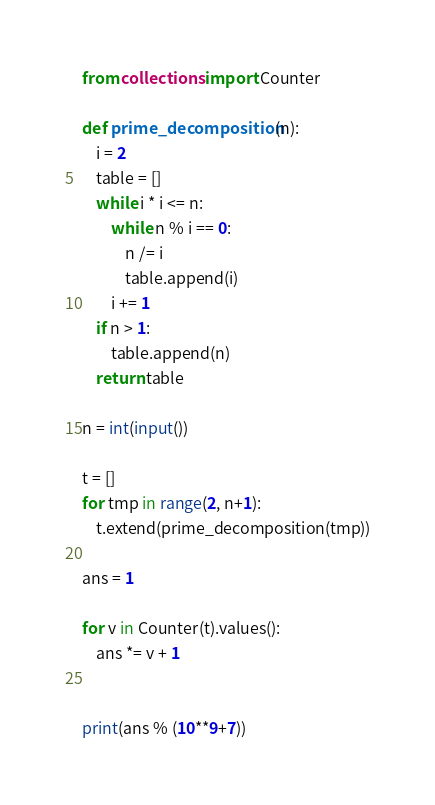<code> <loc_0><loc_0><loc_500><loc_500><_Python_>from collections import Counter

def prime_decomposition(n):
    i = 2
    table = []
    while i * i <= n:
        while n % i == 0:
            n /= i
            table.append(i)
        i += 1
    if n > 1:
        table.append(n)
    return table

n = int(input())

t = []
for tmp in range(2, n+1):
    t.extend(prime_decomposition(tmp))

ans = 1

for v in Counter(t).values():
    ans *= v + 1


print(ans % (10**9+7))
</code> 